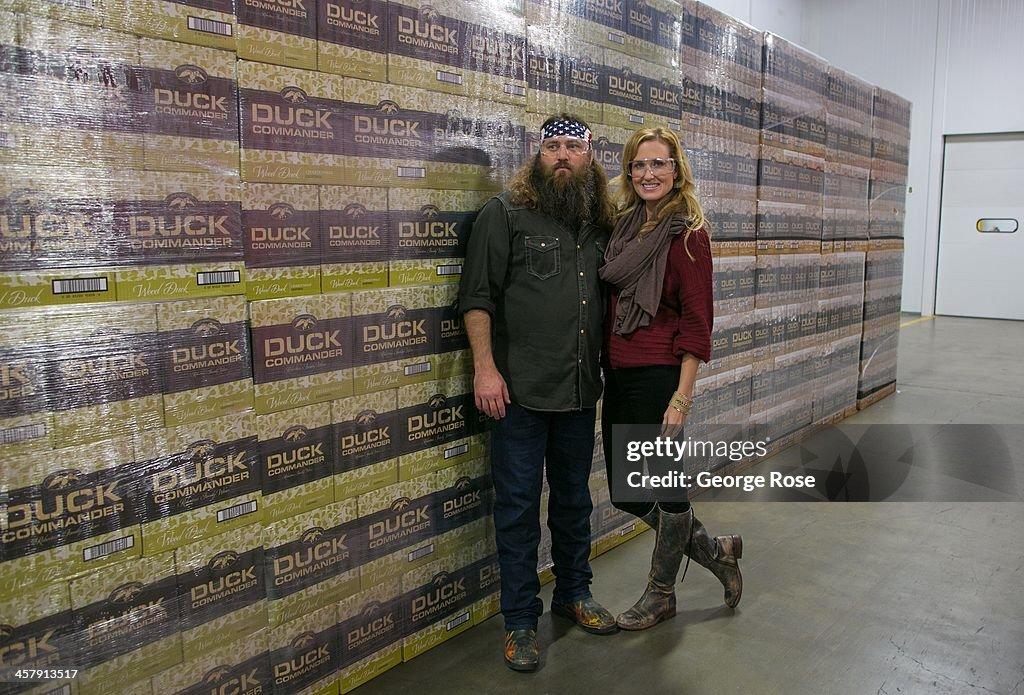Describe the potential atmosphere and smells in the storage area depicted in the image. The storage area likely has a cool, crisp atmosphere, given the clean and organized setting. The smells might range from the earthy and natural scent of cardboard and paper packaging to faint traces of the outdoors, possibly woodsy or mossy undertones linked to the hunting products. There's also a chance of smelling the subtle aroma of oils or substances used to maintain the hunting gear. Can you speculate on how this company might celebrate reaching sales milestones? Given the dedication likely present in their work culture, the celebration of sales milestones at Duck Commander could be a lively and heartfelt event. It might include a company-wide gathering with speeches from key figures reflecting on their journey and achievements. There might be outdoor activities such as group hunts, camping trips, or BBQs to resonate with their brand ethos. Additionally, it's possible they could recognize employees' contributions with awards and incentives, fostering a sense of camaraderie and accomplishment. Imagine a fantastical scenario where Duck Commander products are used in a historical adventure. What might that look like? Picture a time-travel expedition where Duck Commander products are sent back to the age of early explorers and settlers. Imagine a group of adventurers discovering uncharted territories, equipped not just with rudimentary tools but with advanced duck calls and decoys from the future. Their journey would be fraught with challenges as they navigate dense forests and treacherous swamps, but with their modern gear, they’d establish efficient hunting methods, quickly becoming legendary figures among the native wildlife and early settlements for their uncanny knack in duck hunting, thanks to their mysterious and highly effective tools. What might a typical day in the life of an employee at Duck Commander look like? A typical day for an employee at Duck Commander might start early in the morning, reflecting the company's outdoor roots. Employees could begin their day with a team huddle to discuss goals and tasks for the day. The morning might be spent in the production area, assembling and testing duck calls and other hunting gear to ensure top-notch quality. Midday could involve a lunch break where employees share hunting stories or the latest outdoor adventures. The afternoon might be dedicated to packaging products, managing inventory, and addressing customer queries. Employees might also participate in marketing meetings or content creation sessions for promotional materials. The day might wind down with a satisfied review of daily accomplishments and plans for upcoming hunting seasons or product launches. Describe a day when the founder shares an epic hunting story that boosts team morale. On a crisp morning, the Duck Commander team gathers eagerly in the break room, steaming coffee in hand, knowing today’s tale from the founder will be exceptional. As the founder takes the stage, a hush falls over the crowd. He begins his epic hunting story, recounting a foggy marshland adventure where he showcased unmatched skill and bravery. Describing encounters with elusive ducks and the clever use of their signature duck calls, he paints a vivid picture of determination, strategy, and triumph. As the story unfolds, the team’s spirits lift, with laughter and gasps of awe punctuating the tale. By the end, the room buzzes with renewed energy and excitement, each employee fueled with a sense of pride and purpose, ready to channel that inspiration into their work. 